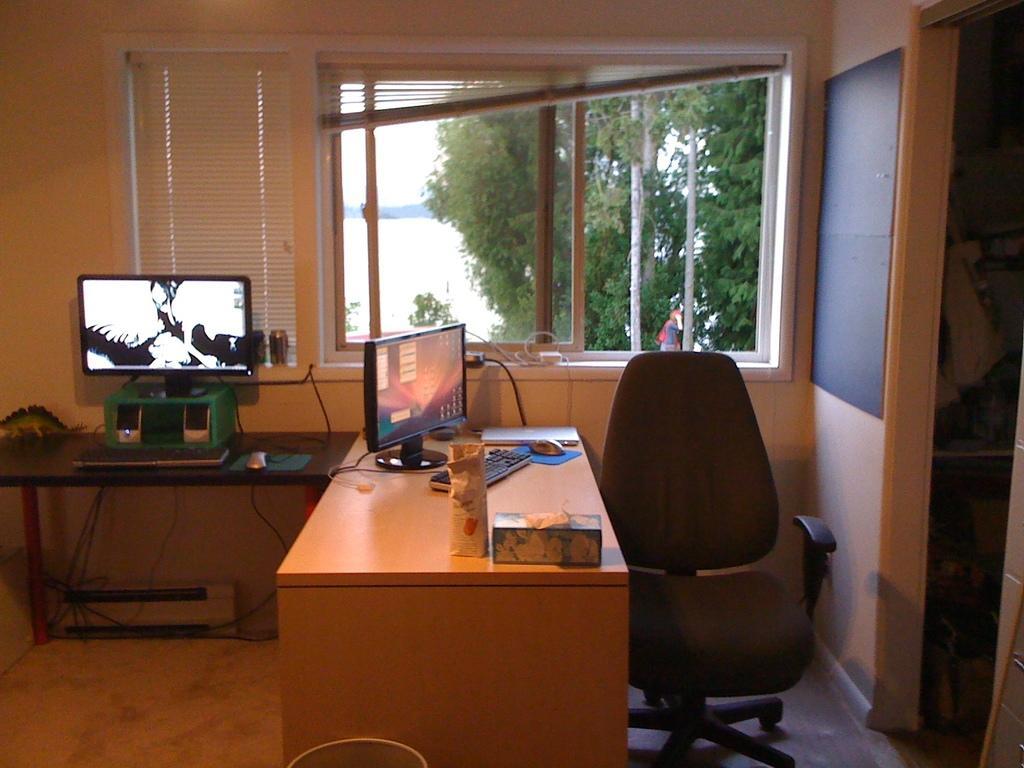Could you give a brief overview of what you see in this image? In this image there is a table on that table there are monitors, keyboard and some objects, beside the table there is a chair ,beside the chair there is a wall to that wall there is a door, in the 